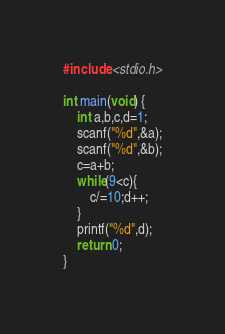<code> <loc_0><loc_0><loc_500><loc_500><_C_>#include <stdio.h>

int main(void) {
	int a,b,c,d=1;
	scanf("%d",&a);
	scanf("%d",&b);
	c=a+b;
	while(9<c){
		c/=10;d++;
	}
	printf("%d",d);
	return 0;
}</code> 